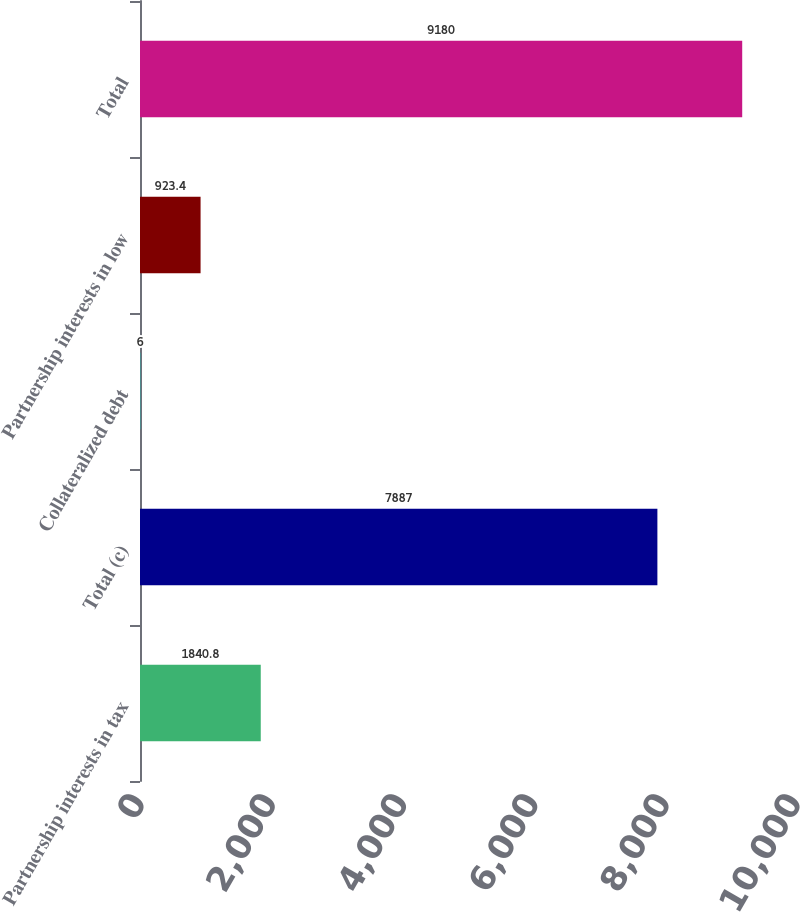Convert chart to OTSL. <chart><loc_0><loc_0><loc_500><loc_500><bar_chart><fcel>Partnership interests in tax<fcel>Total (c)<fcel>Collateralized debt<fcel>Partnership interests in low<fcel>Total<nl><fcel>1840.8<fcel>7887<fcel>6<fcel>923.4<fcel>9180<nl></chart> 